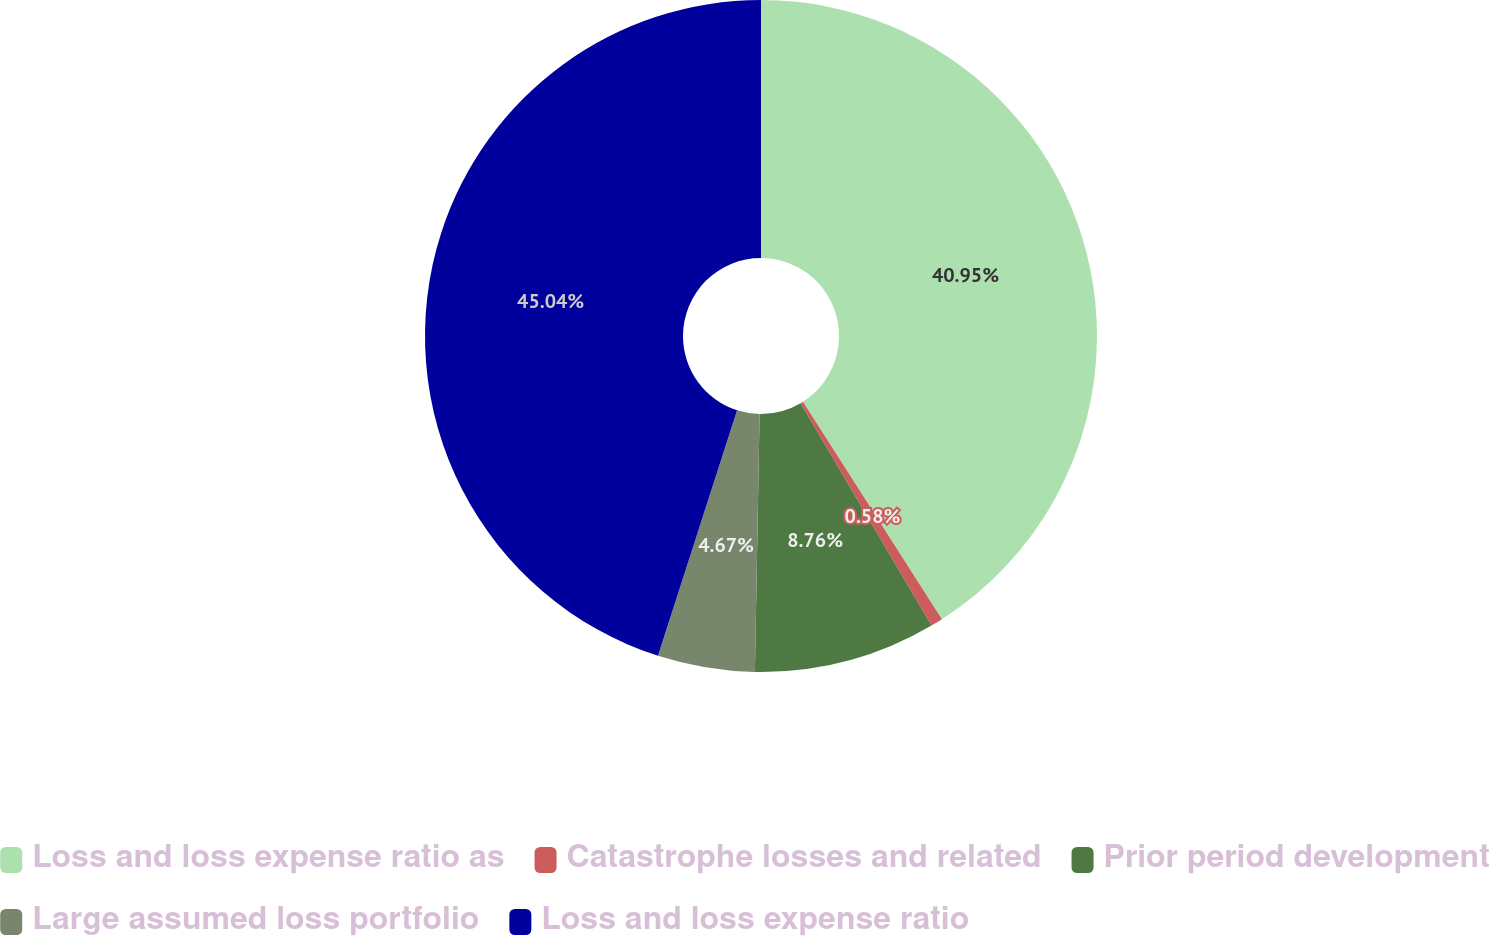Convert chart to OTSL. <chart><loc_0><loc_0><loc_500><loc_500><pie_chart><fcel>Loss and loss expense ratio as<fcel>Catastrophe losses and related<fcel>Prior period development<fcel>Large assumed loss portfolio<fcel>Loss and loss expense ratio<nl><fcel>40.95%<fcel>0.58%<fcel>8.76%<fcel>4.67%<fcel>45.04%<nl></chart> 